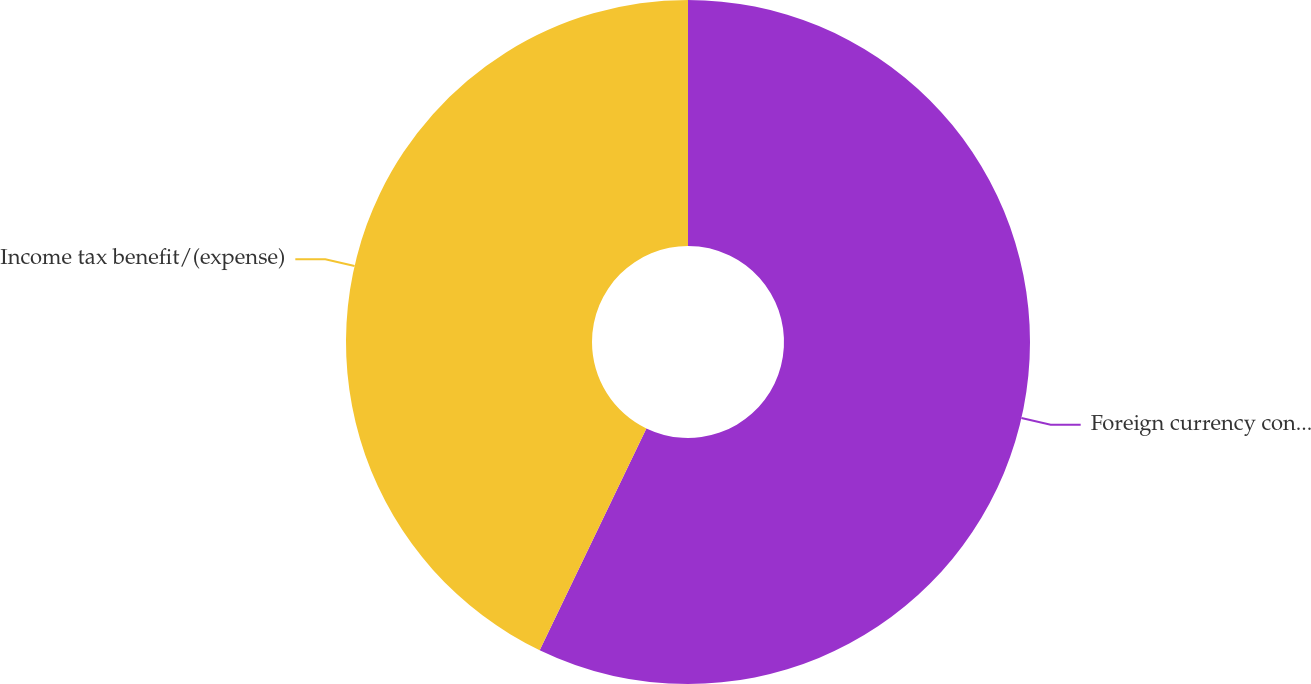Convert chart. <chart><loc_0><loc_0><loc_500><loc_500><pie_chart><fcel>Foreign currency contracts<fcel>Income tax benefit/(expense)<nl><fcel>57.14%<fcel>42.86%<nl></chart> 